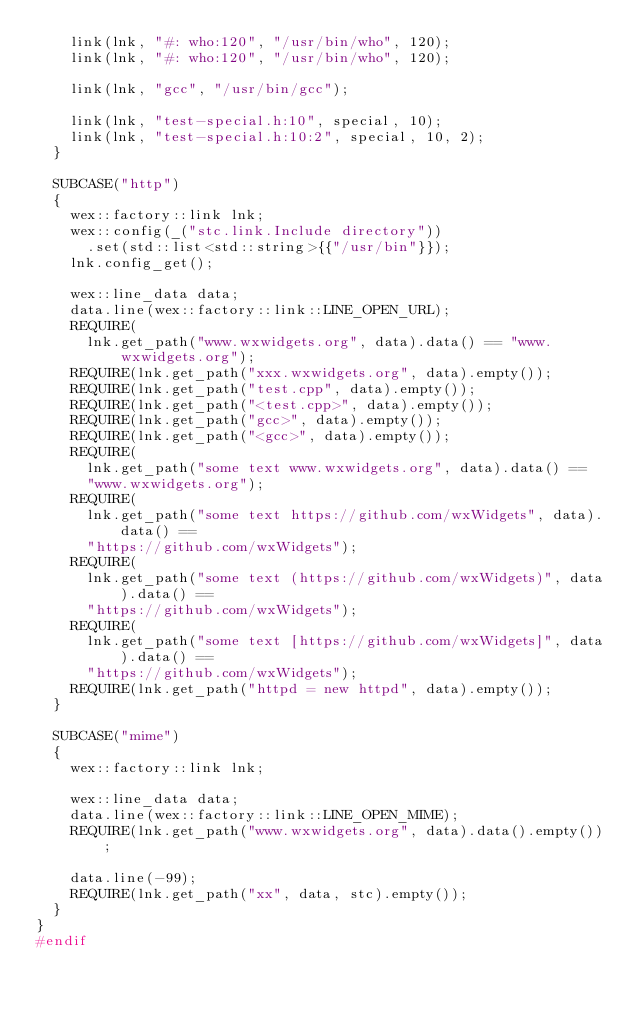<code> <loc_0><loc_0><loc_500><loc_500><_C++_>    link(lnk, "#: who:120", "/usr/bin/who", 120);
    link(lnk, "#: who:120", "/usr/bin/who", 120);

    link(lnk, "gcc", "/usr/bin/gcc");

    link(lnk, "test-special.h:10", special, 10);
    link(lnk, "test-special.h:10:2", special, 10, 2);
  }

  SUBCASE("http")
  {
    wex::factory::link lnk;
    wex::config(_("stc.link.Include directory"))
      .set(std::list<std::string>{{"/usr/bin"}});
    lnk.config_get();

    wex::line_data data;
    data.line(wex::factory::link::LINE_OPEN_URL);
    REQUIRE(
      lnk.get_path("www.wxwidgets.org", data).data() == "www.wxwidgets.org");
    REQUIRE(lnk.get_path("xxx.wxwidgets.org", data).empty());
    REQUIRE(lnk.get_path("test.cpp", data).empty());
    REQUIRE(lnk.get_path("<test.cpp>", data).empty());
    REQUIRE(lnk.get_path("gcc>", data).empty());
    REQUIRE(lnk.get_path("<gcc>", data).empty());
    REQUIRE(
      lnk.get_path("some text www.wxwidgets.org", data).data() ==
      "www.wxwidgets.org");
    REQUIRE(
      lnk.get_path("some text https://github.com/wxWidgets", data).data() ==
      "https://github.com/wxWidgets");
    REQUIRE(
      lnk.get_path("some text (https://github.com/wxWidgets)", data).data() ==
      "https://github.com/wxWidgets");
    REQUIRE(
      lnk.get_path("some text [https://github.com/wxWidgets]", data).data() ==
      "https://github.com/wxWidgets");
    REQUIRE(lnk.get_path("httpd = new httpd", data).empty());
  }

  SUBCASE("mime")
  {
    wex::factory::link lnk;

    wex::line_data data;
    data.line(wex::factory::link::LINE_OPEN_MIME);
    REQUIRE(lnk.get_path("www.wxwidgets.org", data).data().empty());

    data.line(-99);
    REQUIRE(lnk.get_path("xx", data, stc).empty());
  }
}
#endif
</code> 